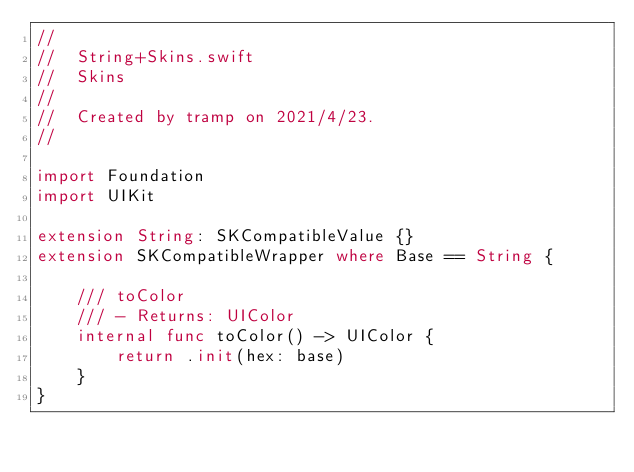Convert code to text. <code><loc_0><loc_0><loc_500><loc_500><_Swift_>//
//  String+Skins.swift
//  Skins
//
//  Created by tramp on 2021/4/23.
//

import Foundation
import UIKit

extension String: SKCompatibleValue {}
extension SKCompatibleWrapper where Base == String {
    
    /// toColor
    /// - Returns: UIColor
    internal func toColor() -> UIColor {
        return .init(hex: base)
    }
}
</code> 